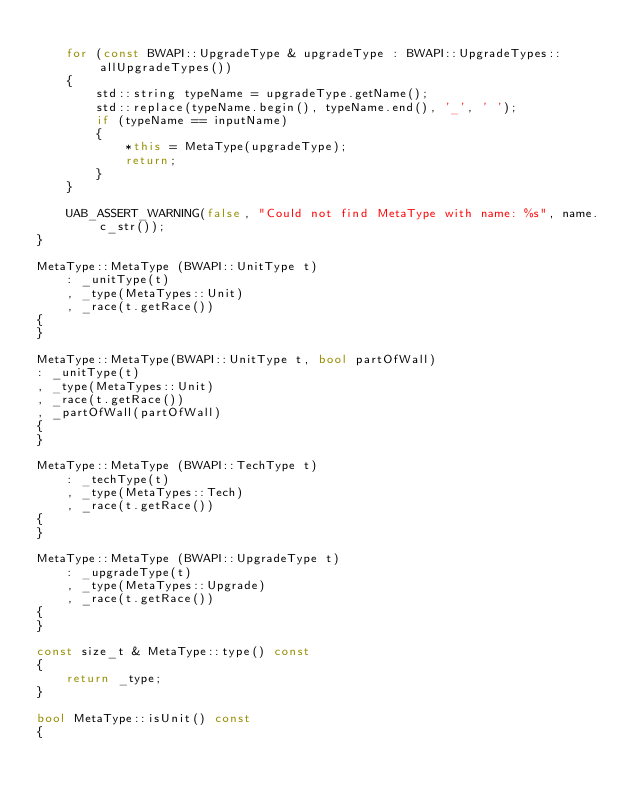Convert code to text. <code><loc_0><loc_0><loc_500><loc_500><_C++_>
    for (const BWAPI::UpgradeType & upgradeType : BWAPI::UpgradeTypes::allUpgradeTypes())
    {
        std::string typeName = upgradeType.getName();
        std::replace(typeName.begin(), typeName.end(), '_', ' ');
        if (typeName == inputName)
        {
            *this = MetaType(upgradeType);
            return;
        }
    }

    UAB_ASSERT_WARNING(false, "Could not find MetaType with name: %s", name.c_str());
}

MetaType::MetaType (BWAPI::UnitType t) 
    : _unitType(t)
    , _type(MetaTypes::Unit) 
    , _race(t.getRace())
{
}

MetaType::MetaType(BWAPI::UnitType t, bool partOfWall)
: _unitType(t)
, _type(MetaTypes::Unit)
, _race(t.getRace())
, _partOfWall(partOfWall)
{
}

MetaType::MetaType (BWAPI::TechType t) 
    : _techType(t)
    , _type(MetaTypes::Tech) 
    , _race(t.getRace())
{
}

MetaType::MetaType (BWAPI::UpgradeType t) 
    : _upgradeType(t)
    , _type(MetaTypes::Upgrade) 
    , _race(t.getRace())
{
}

const size_t & MetaType::type() const
{
    return _type;
}

bool MetaType::isUnit() const 
{</code> 